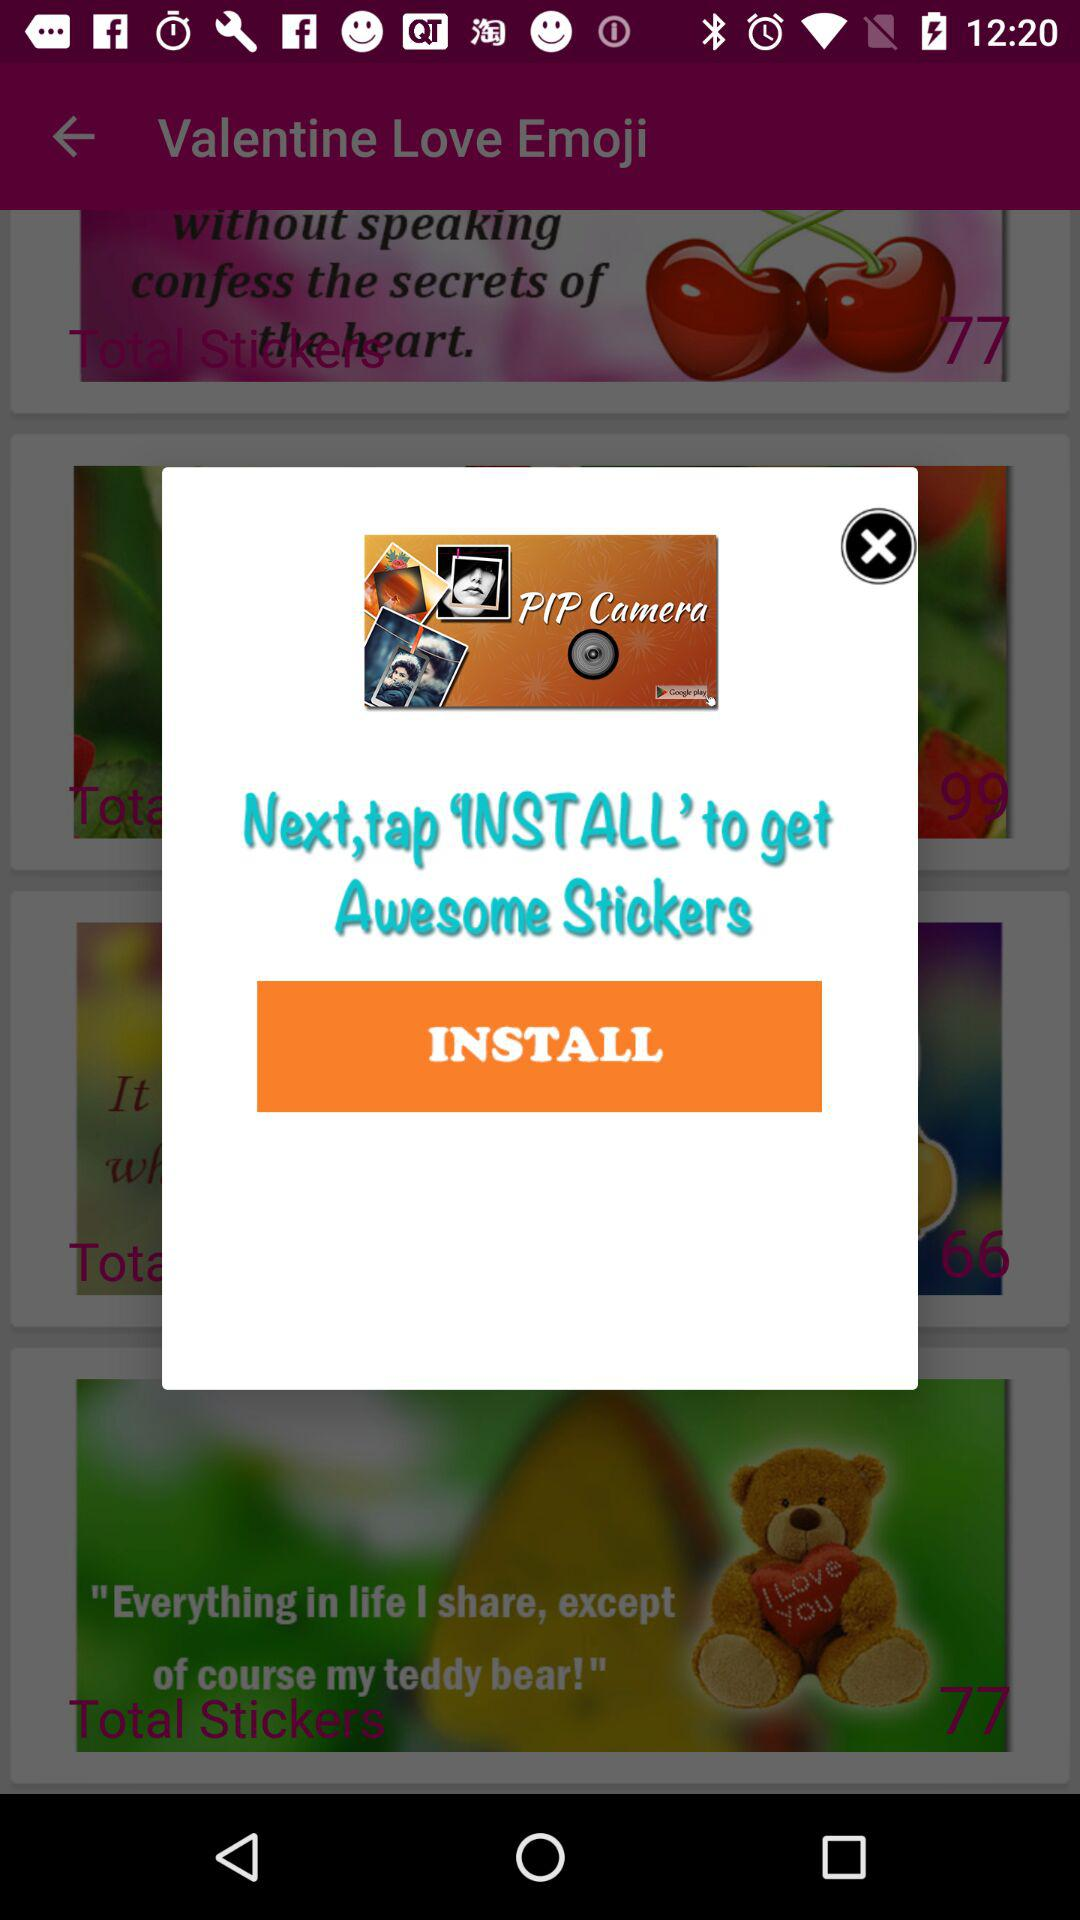Where to tap to get awesome stickers? Tap on "INSTALL" to get awesome stickers. 